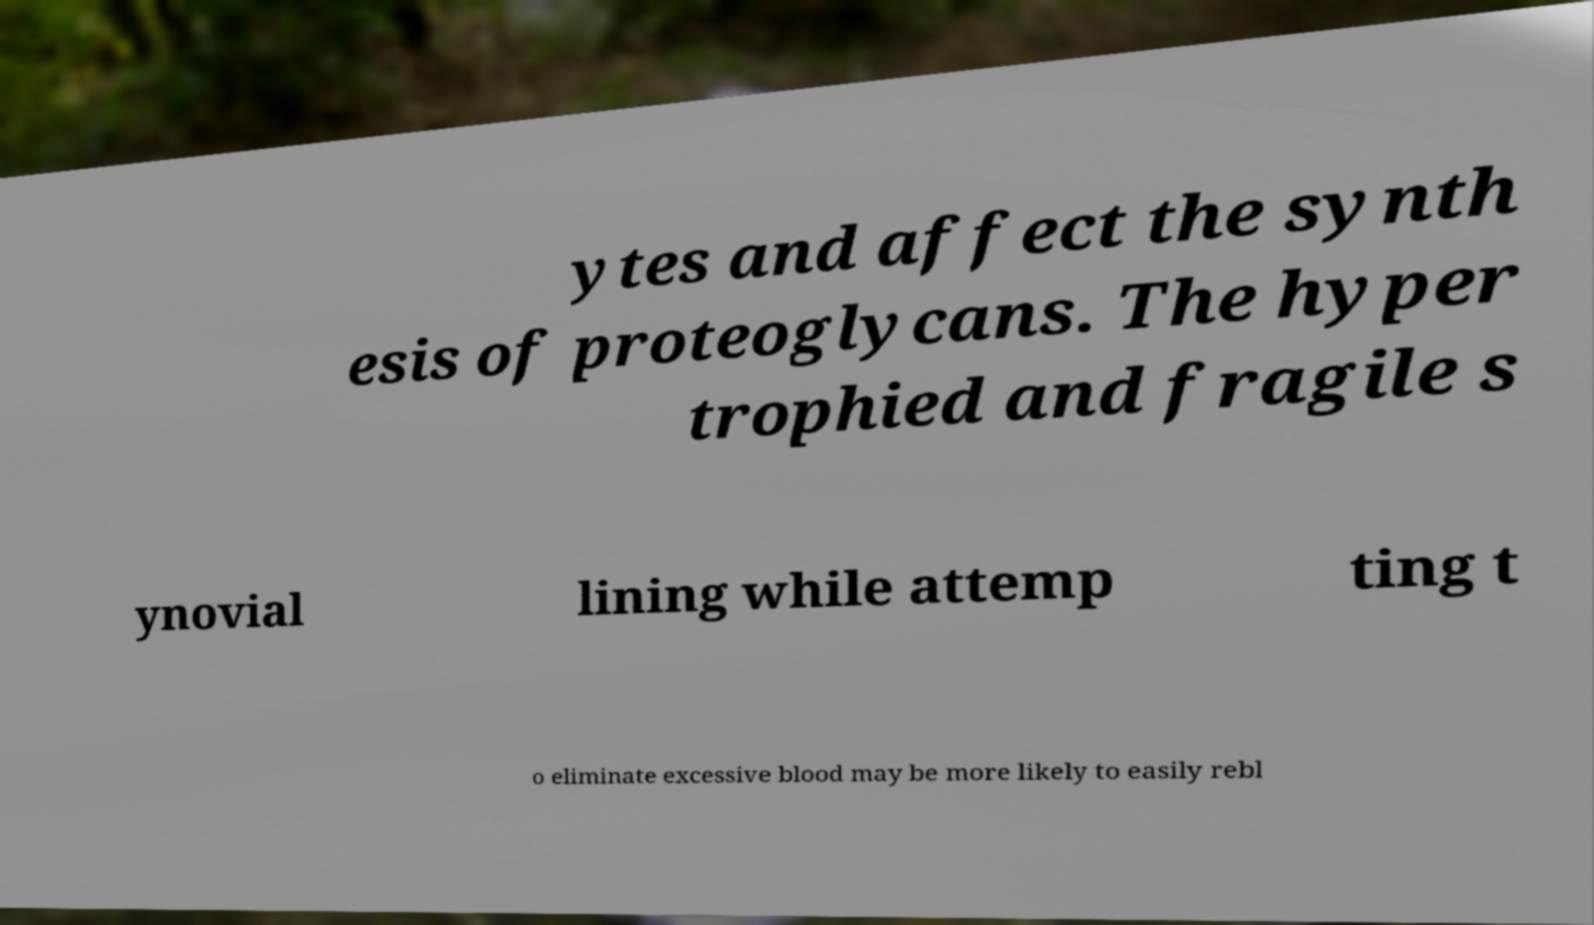Can you accurately transcribe the text from the provided image for me? ytes and affect the synth esis of proteoglycans. The hyper trophied and fragile s ynovial lining while attemp ting t o eliminate excessive blood may be more likely to easily rebl 